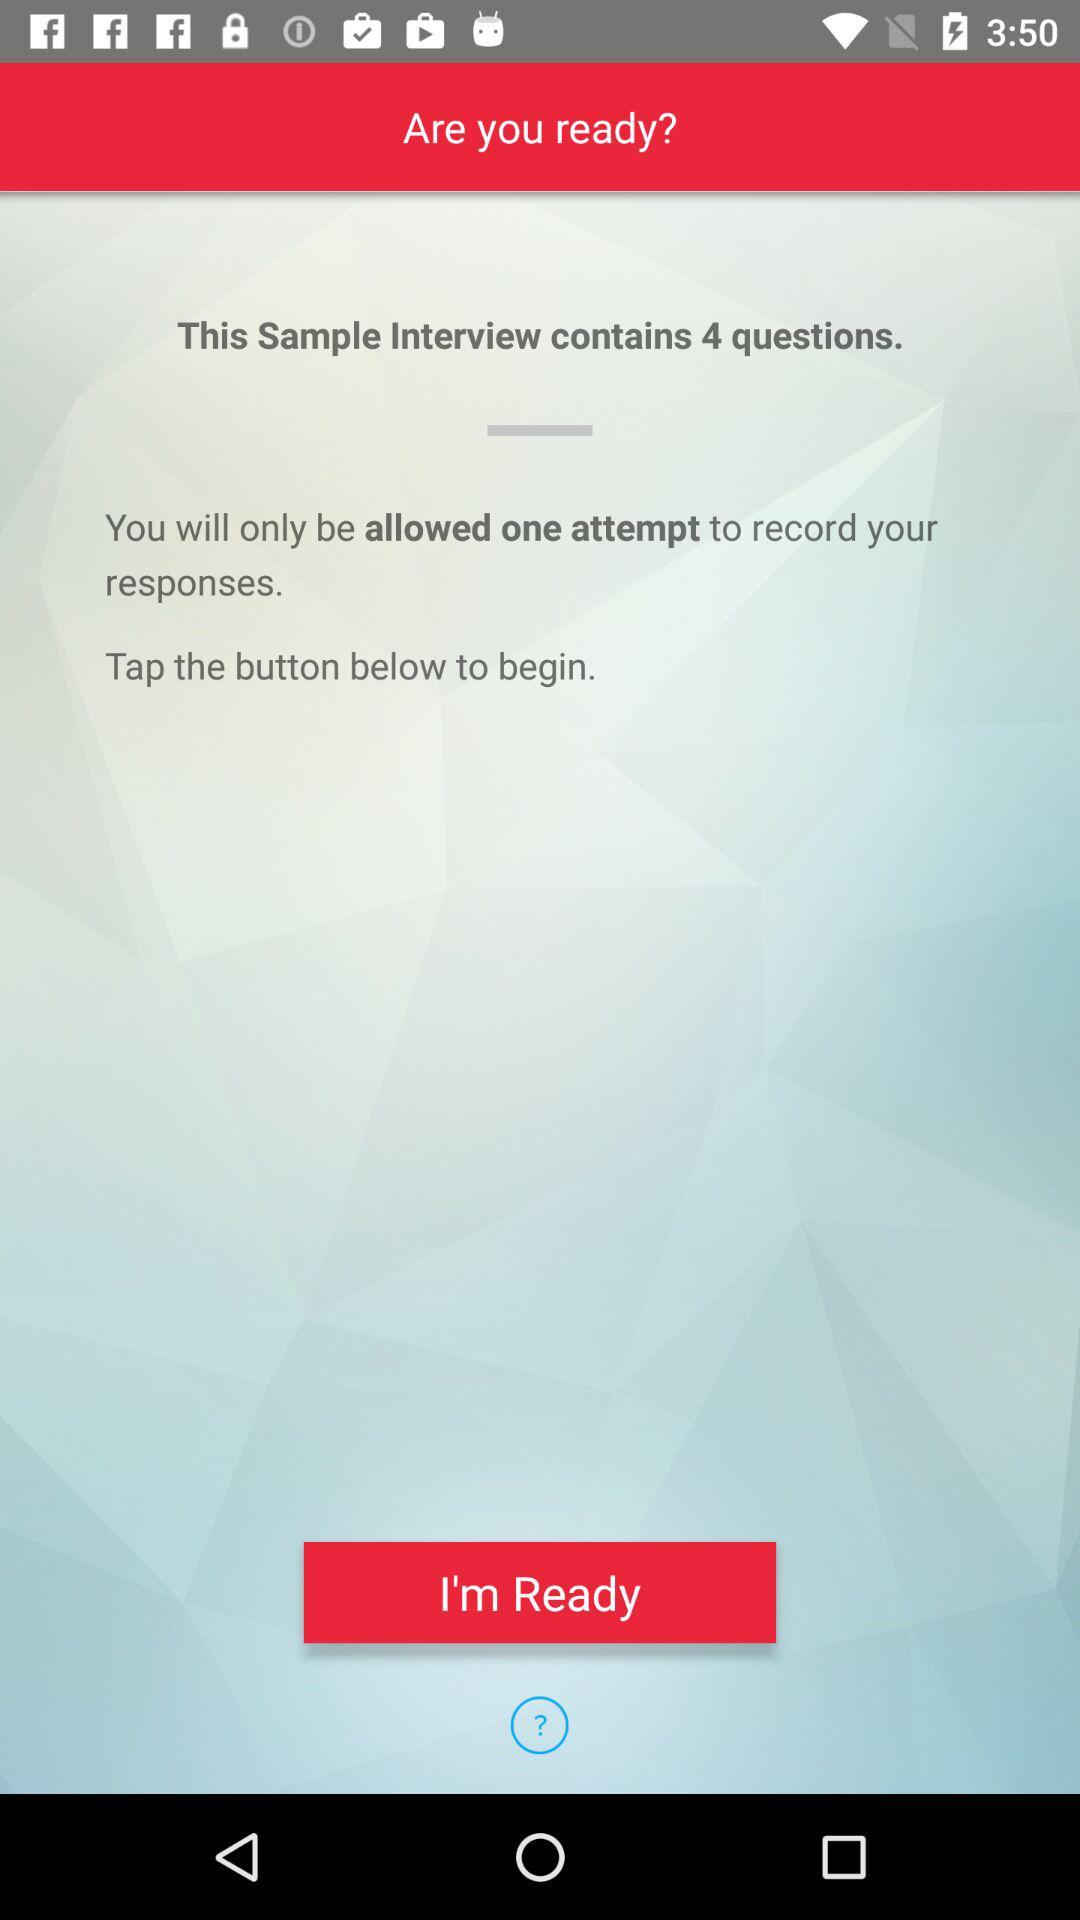How many questions does the "Sample Interview" contain? The "Sample Interview" contains 4 questions. 